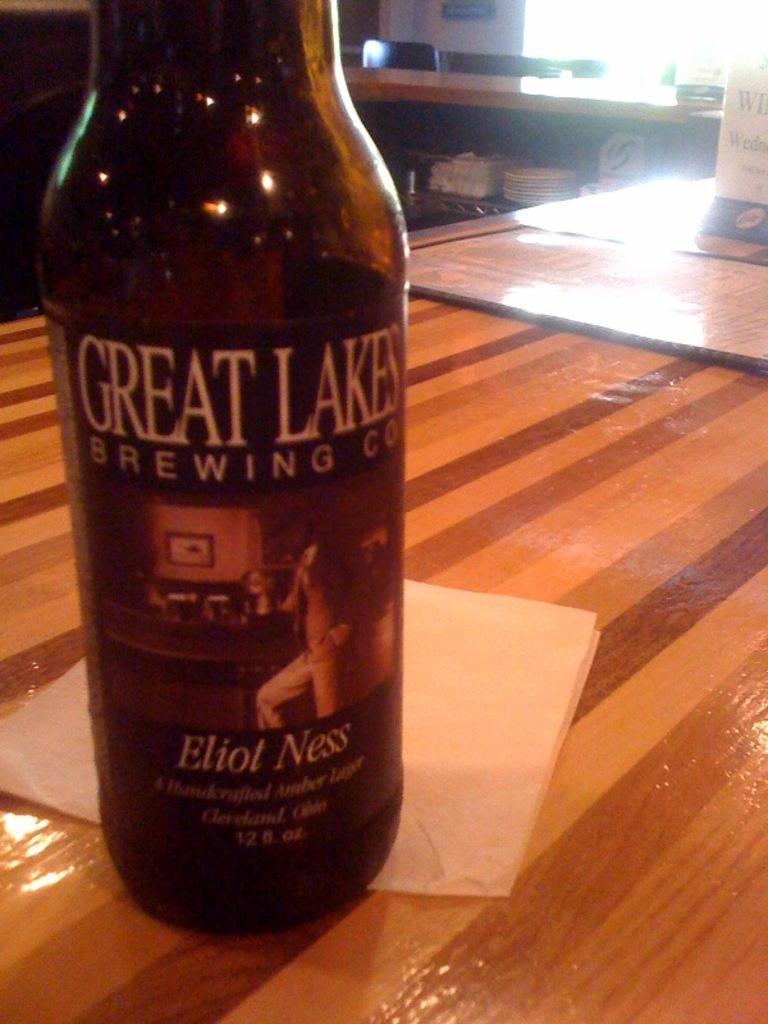<image>
Share a concise interpretation of the image provided. A bottle says "GREAT LAKES BREWING CO" on the front. 